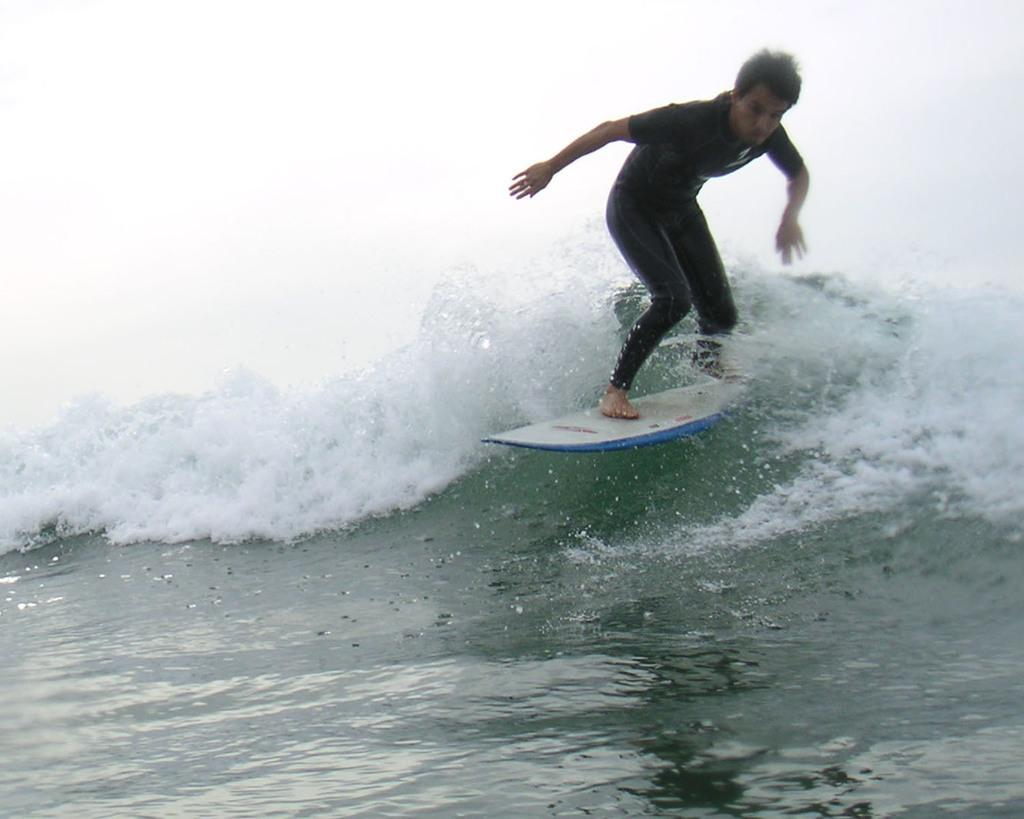Where was the image taken? The image is taken outdoors. What can be seen at the bottom of the image? There is a sea with waves at the bottom of the image. What is the man doing in the image? A man is surfing in the sea. What tool is the man using to surf? The man is using a surfing board. What type of badge can be seen on the surfing board? There is no badge present on the surfing board in the image. 